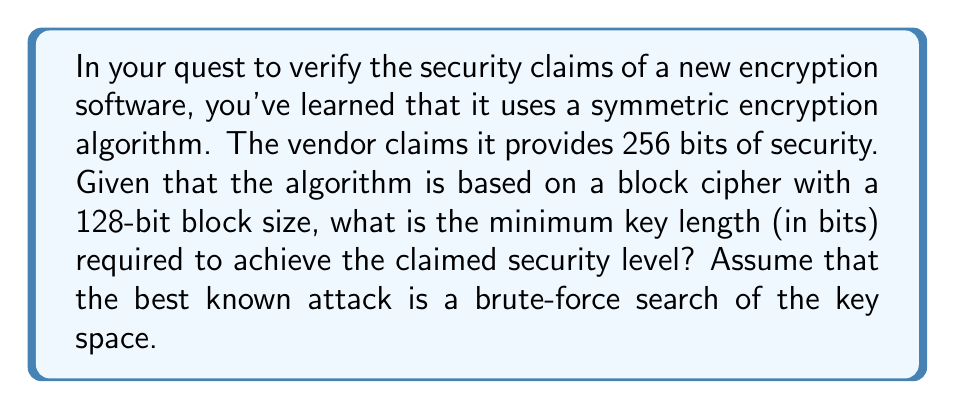Help me with this question. To solve this problem, we need to understand the relationship between key length and security level in symmetric encryption. Let's break it down step-by-step:

1) In symmetric encryption, the security level is typically measured by the number of operations required to break the encryption through a brute-force attack.

2) For a key of length $n$ bits, there are $2^n$ possible keys.

3) On average, an attacker would need to try half of all possible keys before finding the correct one. This is represented by:

   $$\text{Number of operations} = \frac{2^n}{2} = 2^{n-1}$$

4) The claimed security level is 256 bits, which means the number of operations required should be $2^{256}$.

5) We can set up the equation:

   $$2^{n-1} = 2^{256}$$

6) Taking the logarithm (base 2) of both sides:

   $$n - 1 = 256$$

7) Solving for $n$:

   $$n = 257$$

Therefore, the minimum key length required to achieve 256 bits of security is 257 bits.

It's worth noting that in practice, key lengths are typically chosen to be powers of 2 for implementation efficiency. So in reality, a 512-bit key would likely be used to exceed the 256-bit security level.
Answer: 257 bits 